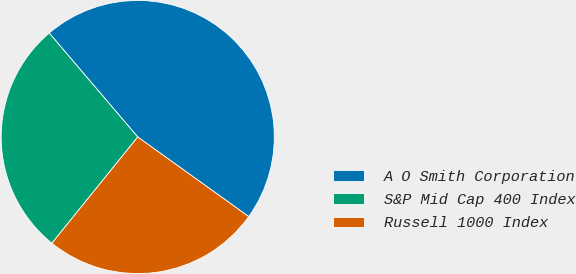<chart> <loc_0><loc_0><loc_500><loc_500><pie_chart><fcel>A O Smith Corporation<fcel>S&P Mid Cap 400 Index<fcel>Russell 1000 Index<nl><fcel>46.13%<fcel>27.95%<fcel>25.92%<nl></chart> 